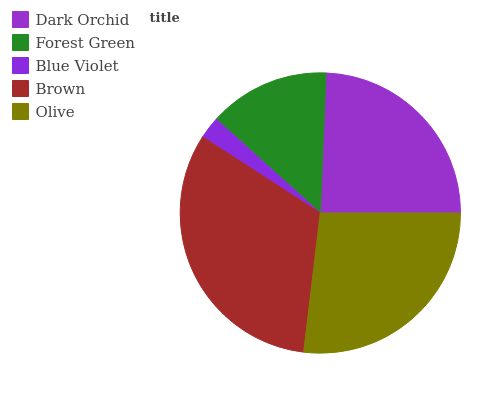Is Blue Violet the minimum?
Answer yes or no. Yes. Is Brown the maximum?
Answer yes or no. Yes. Is Forest Green the minimum?
Answer yes or no. No. Is Forest Green the maximum?
Answer yes or no. No. Is Dark Orchid greater than Forest Green?
Answer yes or no. Yes. Is Forest Green less than Dark Orchid?
Answer yes or no. Yes. Is Forest Green greater than Dark Orchid?
Answer yes or no. No. Is Dark Orchid less than Forest Green?
Answer yes or no. No. Is Dark Orchid the high median?
Answer yes or no. Yes. Is Dark Orchid the low median?
Answer yes or no. Yes. Is Brown the high median?
Answer yes or no. No. Is Forest Green the low median?
Answer yes or no. No. 